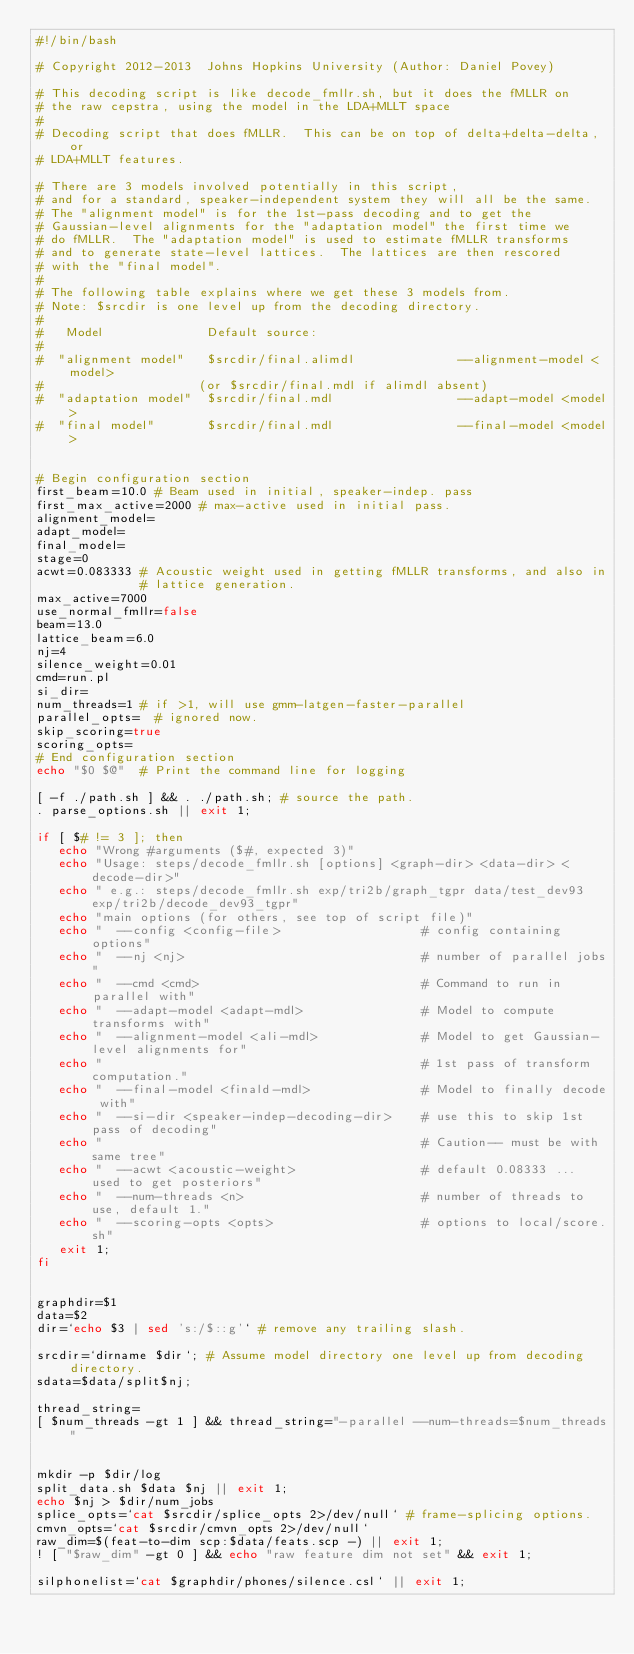Convert code to text. <code><loc_0><loc_0><loc_500><loc_500><_Bash_>#!/bin/bash

# Copyright 2012-2013  Johns Hopkins University (Author: Daniel Povey)

# This decoding script is like decode_fmllr.sh, but it does the fMLLR on
# the raw cepstra, using the model in the LDA+MLLT space
#
# Decoding script that does fMLLR.  This can be on top of delta+delta-delta, or
# LDA+MLLT features.

# There are 3 models involved potentially in this script,
# and for a standard, speaker-independent system they will all be the same.
# The "alignment model" is for the 1st-pass decoding and to get the
# Gaussian-level alignments for the "adaptation model" the first time we
# do fMLLR.  The "adaptation model" is used to estimate fMLLR transforms
# and to generate state-level lattices.  The lattices are then rescored
# with the "final model".
#
# The following table explains where we get these 3 models from.
# Note: $srcdir is one level up from the decoding directory.
#
#   Model              Default source:
#
#  "alignment model"   $srcdir/final.alimdl              --alignment-model <model>
#                     (or $srcdir/final.mdl if alimdl absent)
#  "adaptation model"  $srcdir/final.mdl                 --adapt-model <model>
#  "final model"       $srcdir/final.mdl                 --final-model <model>


# Begin configuration section
first_beam=10.0 # Beam used in initial, speaker-indep. pass
first_max_active=2000 # max-active used in initial pass.
alignment_model=
adapt_model=
final_model=
stage=0
acwt=0.083333 # Acoustic weight used in getting fMLLR transforms, and also in
              # lattice generation.
max_active=7000
use_normal_fmllr=false
beam=13.0
lattice_beam=6.0
nj=4
silence_weight=0.01
cmd=run.pl
si_dir=
num_threads=1 # if >1, will use gmm-latgen-faster-parallel
parallel_opts=  # ignored now.
skip_scoring=true
scoring_opts=
# End configuration section
echo "$0 $@"  # Print the command line for logging

[ -f ./path.sh ] && . ./path.sh; # source the path.
. parse_options.sh || exit 1;

if [ $# != 3 ]; then
   echo "Wrong #arguments ($#, expected 3)"
   echo "Usage: steps/decode_fmllr.sh [options] <graph-dir> <data-dir> <decode-dir>"
   echo " e.g.: steps/decode_fmllr.sh exp/tri2b/graph_tgpr data/test_dev93 exp/tri2b/decode_dev93_tgpr"
   echo "main options (for others, see top of script file)"
   echo "  --config <config-file>                   # config containing options"
   echo "  --nj <nj>                                # number of parallel jobs"
   echo "  --cmd <cmd>                              # Command to run in parallel with"
   echo "  --adapt-model <adapt-mdl>                # Model to compute transforms with"
   echo "  --alignment-model <ali-mdl>              # Model to get Gaussian-level alignments for"
   echo "                                           # 1st pass of transform computation."
   echo "  --final-model <finald-mdl>               # Model to finally decode with"
   echo "  --si-dir <speaker-indep-decoding-dir>    # use this to skip 1st pass of decoding"
   echo "                                           # Caution-- must be with same tree"
   echo "  --acwt <acoustic-weight>                 # default 0.08333 ... used to get posteriors"
   echo "  --num-threads <n>                        # number of threads to use, default 1."
   echo "  --scoring-opts <opts>                    # options to local/score.sh"
   exit 1;
fi


graphdir=$1
data=$2
dir=`echo $3 | sed 's:/$::g'` # remove any trailing slash.

srcdir=`dirname $dir`; # Assume model directory one level up from decoding directory.
sdata=$data/split$nj;

thread_string=
[ $num_threads -gt 1 ] && thread_string="-parallel --num-threads=$num_threads"


mkdir -p $dir/log
split_data.sh $data $nj || exit 1;
echo $nj > $dir/num_jobs
splice_opts=`cat $srcdir/splice_opts 2>/dev/null` # frame-splicing options.
cmvn_opts=`cat $srcdir/cmvn_opts 2>/dev/null`
raw_dim=$(feat-to-dim scp:$data/feats.scp -) || exit 1;
! [ "$raw_dim" -gt 0 ] && echo "raw feature dim not set" && exit 1;

silphonelist=`cat $graphdir/phones/silence.csl` || exit 1;
</code> 